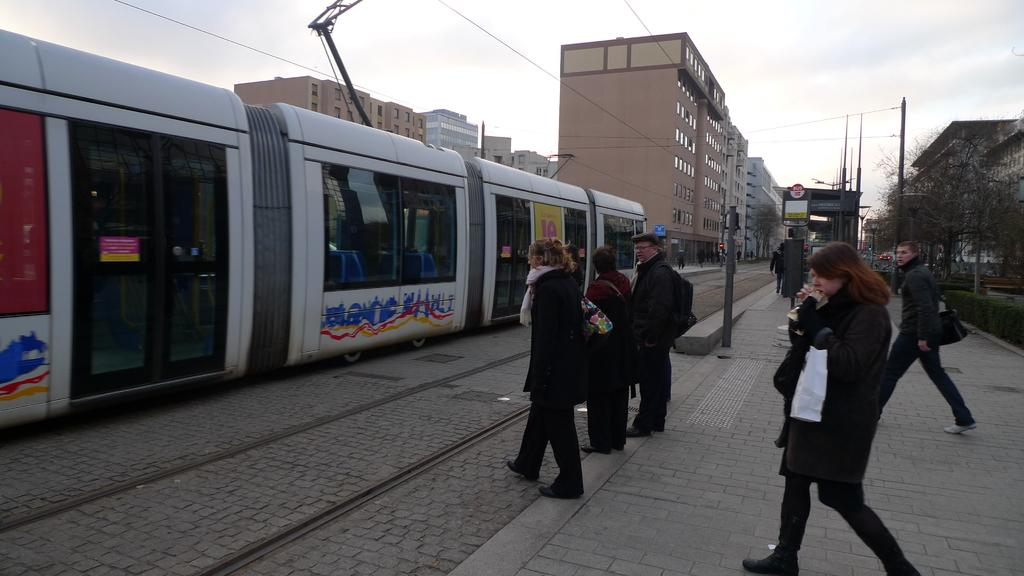What is the main subject of the image? The main subject of the image is a train on the track. Can you describe the people visible in the image? There are people visible in the image, but their specific actions or characteristics are not mentioned in the facts. What other objects or structures can be seen in the image? There are poles, trees, boards, and buildings visible in the image. What is visible in the background of the image? The sky is visible in the background of the image. What type of liquid is being poured by the beginner in the image? There is no beginner or liquid present in the image. The image features a train on the track, people, poles, trees, boards, buildings, and a visible sky in the background. 